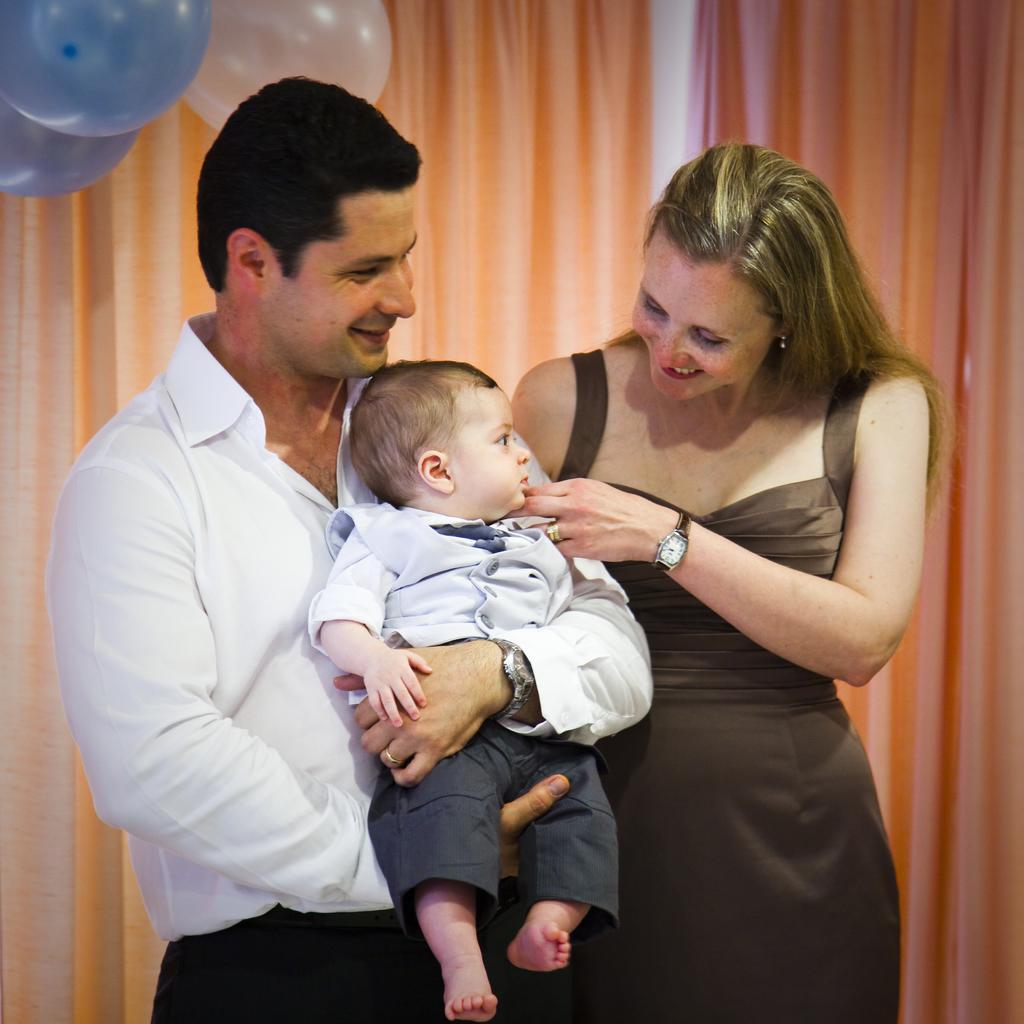How would you summarize this image in a sentence or two? In the center of the image, we can see a man holding a kid and there is a lady. In the background, there are balloons and we can see a curtain. 